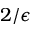Convert formula to latex. <formula><loc_0><loc_0><loc_500><loc_500>2 / \epsilon</formula> 